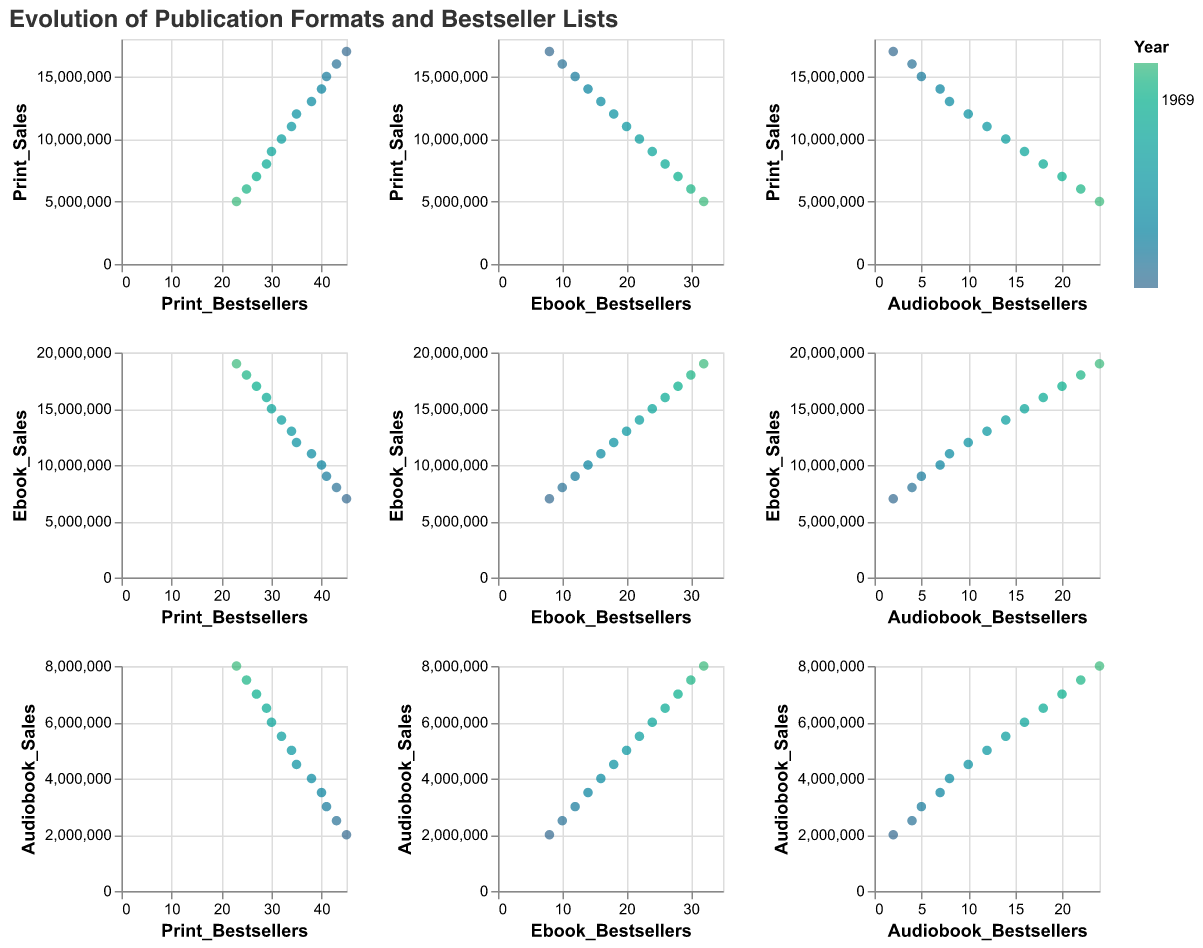What is the relationship between Print_Sales and Print_Bestsellers over the years? Print_Sales tends to decrease over the years while the number of Print_Bestsellers also decreases, indicating a possible correlation between declining print sales and fewer bestsellers in print format.
Answer: Decreasing How have Ebook_Sales and Ebook_Bestsellers changed from 2010 to 2022? Ebook_Sales have increased from 7,000,000 to 19,000,000 while Ebook_Bestsellers have increased from 8 to 32 over the same time period. This indicates a consistent growth in both ebook sales and the number of ebook bestsellers.
Answer: Both increased Compare the number of Audiobook_Bestsellers with Print_Bestsellers in 2022. In 2022, Audiobook_Bestsellers are at 24 while Print_Bestsellers are at 23, showing that there were slightly more Audiobook_Bestsellers compared to Print_Bestsellers that year.
Answer: Audiobook_Bestsellers are higher Which year shows the highest Ebook_Sales? By looking at the scales along the Ebook_Sales axis, the year 2022 shows the highest Ebook_Sales with 19,000,000.
Answer: 2022 What trend do you observe in Audiobook_Sales and Audiobook_Bestsellers between 2010 and 2022? Both Audiobook_Sales and Audiobook_Bestsellers have consistently increased over the years, indicating a growing popularity of audiobooks. Audiobook_Sales increased from 2,000,000 to 8,000,000, while Audiobook_Bestsellers increased from 2 to 24.
Answer: Increasing trend for both Do Print_Sales correlate with Print_Bestsellers? The scatter plots show a positive correlation where lower Print_Sales generally correspond to fewer Print_Bestsellers, indicating that as print sales decrease, the number of print bestsellers also decreases.
Answer: Yes, positive correlation How do the sales of eBooks compare to the number of eBook bestsellers in 2022? In 2022, Ebook_Sales were 19,000,000 while there were 32 Ebook_Bestsellers, showing that high sales volumes might be related to a higher number of bestsellers in the ebook format.
Answer: High sales, high bestsellers What is the general pattern of how publication formats have evolved in terms of sales from 2010 to 2022? Print_Sales have decreased, Ebook_Sales have increased, and Audiobook_Sales have also increased over these years. This points to a shift from print to digital formats in the publishing industry.
Answer: Shift from print to digital formats In the scatter plot matrix, which format shows the steepest increase in bestsellers over the years? By examining the slope represented by the points in relation to the year, eBooks show the steepest increase in bestsellers, rising from 8 to 32 between 2010 and 2022.
Answer: eBooks Is there a noticeable relationship between Ebook_Sales and Print_Sales? The scatter plots indicate an inverse relationship; as Ebook_Sales have increased, Print_Sales have decreased, depicting a potential market shift from print to digital formats.
Answer: Inverse relationship 